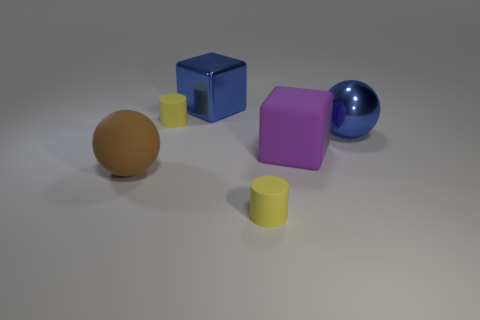Is there a tiny red thing that has the same shape as the big brown object?
Offer a terse response. No. There is a yellow object behind the brown sphere; what is its shape?
Keep it short and to the point. Cylinder. What number of large blue blocks are behind the metallic object that is on the right side of the big block that is in front of the large blue ball?
Offer a terse response. 1. Is the color of the big sphere behind the big rubber block the same as the big rubber cube?
Your response must be concise. No. How many other things are there of the same shape as the large brown rubber object?
Offer a terse response. 1. What number of other objects are the same material as the large blue sphere?
Provide a succinct answer. 1. There is a ball on the right side of the small cylinder to the right of the tiny yellow rubber object behind the large blue sphere; what is its material?
Ensure brevity in your answer.  Metal. Are the big brown sphere and the large blue block made of the same material?
Your answer should be very brief. No. How many blocks are either brown objects or large blue objects?
Your answer should be very brief. 1. There is a tiny cylinder behind the matte block; what is its color?
Keep it short and to the point. Yellow. 